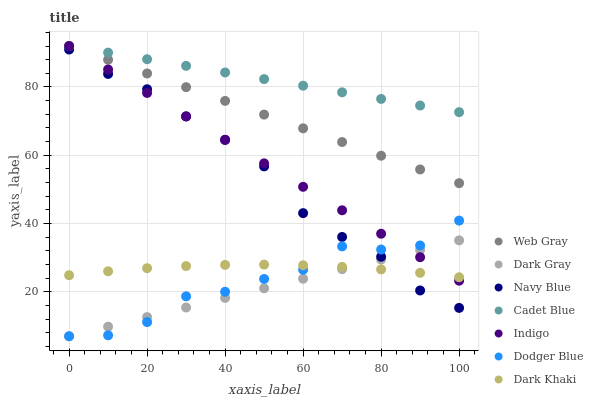Does Dark Gray have the minimum area under the curve?
Answer yes or no. Yes. Does Cadet Blue have the maximum area under the curve?
Answer yes or no. Yes. Does Web Gray have the minimum area under the curve?
Answer yes or no. No. Does Web Gray have the maximum area under the curve?
Answer yes or no. No. Is Web Gray the smoothest?
Answer yes or no. Yes. Is Dodger Blue the roughest?
Answer yes or no. Yes. Is Indigo the smoothest?
Answer yes or no. No. Is Indigo the roughest?
Answer yes or no. No. Does Dark Gray have the lowest value?
Answer yes or no. Yes. Does Web Gray have the lowest value?
Answer yes or no. No. Does Cadet Blue have the highest value?
Answer yes or no. Yes. Does Navy Blue have the highest value?
Answer yes or no. No. Is Dark Gray less than Web Gray?
Answer yes or no. Yes. Is Web Gray greater than Dark Gray?
Answer yes or no. Yes. Does Dark Khaki intersect Navy Blue?
Answer yes or no. Yes. Is Dark Khaki less than Navy Blue?
Answer yes or no. No. Is Dark Khaki greater than Navy Blue?
Answer yes or no. No. Does Dark Gray intersect Web Gray?
Answer yes or no. No. 